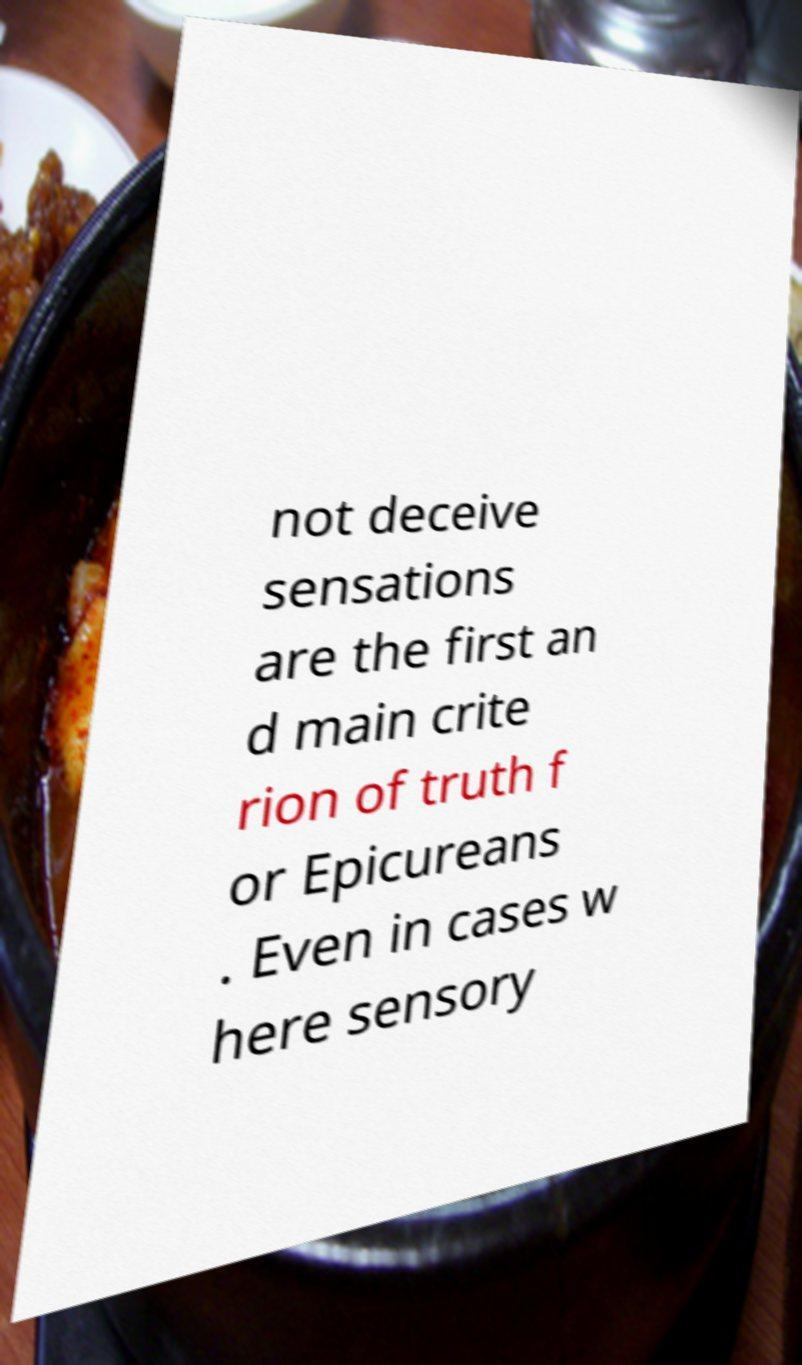I need the written content from this picture converted into text. Can you do that? not deceive sensations are the first an d main crite rion of truth f or Epicureans . Even in cases w here sensory 